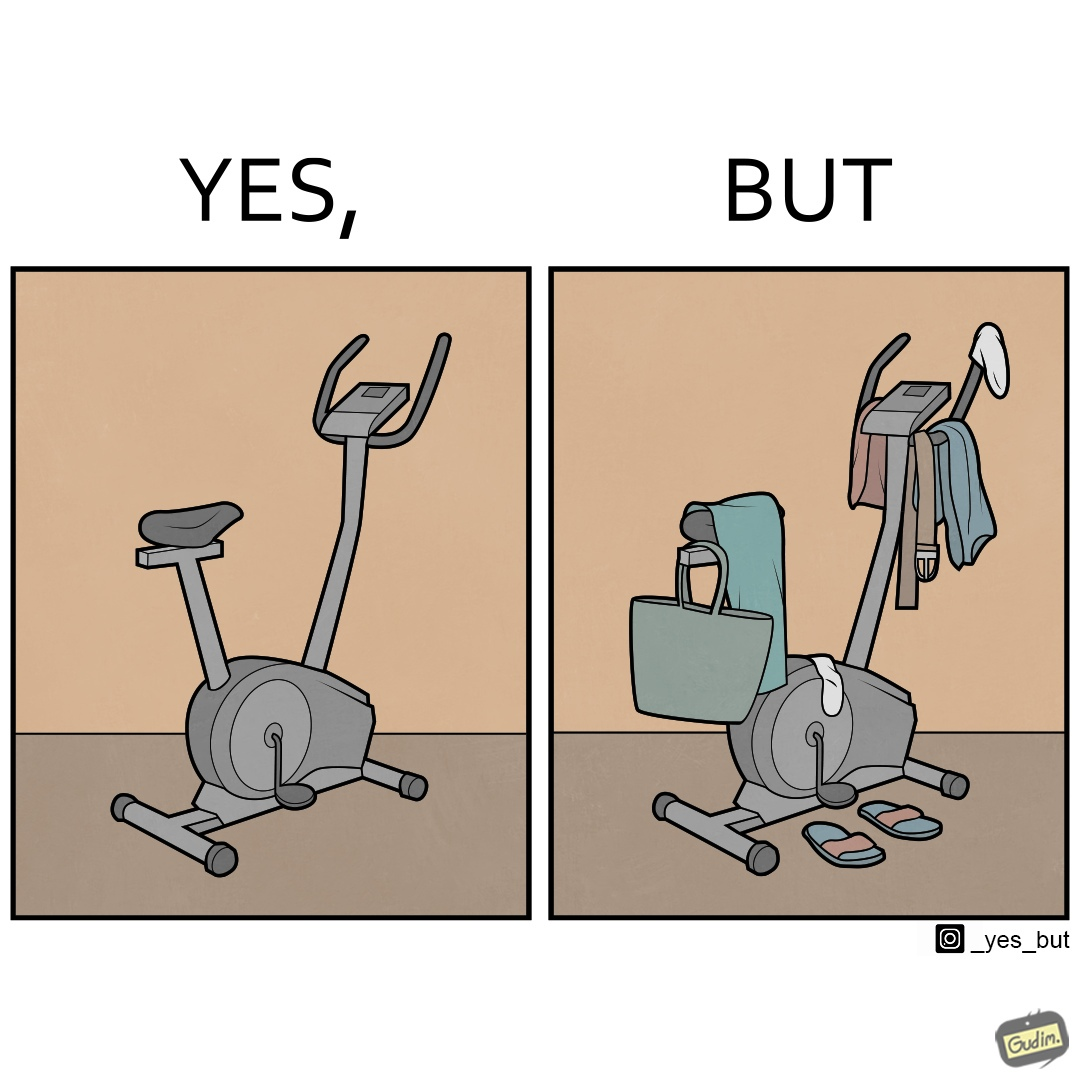What is shown in this image? The images are funny since they show an exercise bike has been bought but is not being used for its purpose, that is, exercising. It is rather being used to hang clothes, bags and other items 